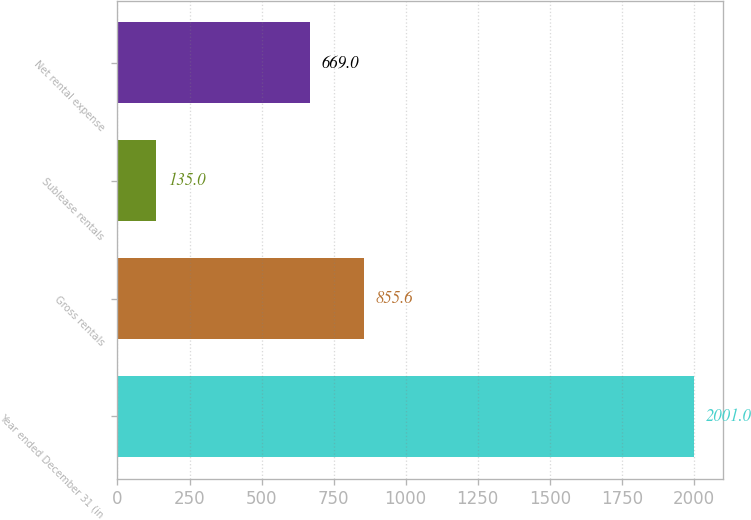Convert chart. <chart><loc_0><loc_0><loc_500><loc_500><bar_chart><fcel>Year ended December 31 (in<fcel>Gross rentals<fcel>Sublease rentals<fcel>Net rental expense<nl><fcel>2001<fcel>855.6<fcel>135<fcel>669<nl></chart> 